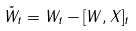Convert formula to latex. <formula><loc_0><loc_0><loc_500><loc_500>\tilde { W } _ { t } = W _ { t } - [ W , X ] _ { t }</formula> 